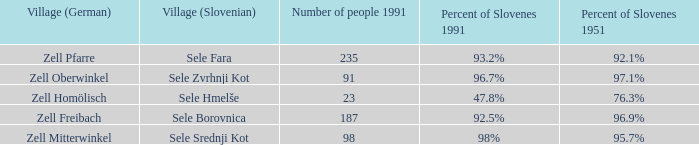Provide with the names of the village (German) that is part of village (Slovenian) with sele srednji kot. Zell Mitterwinkel. 